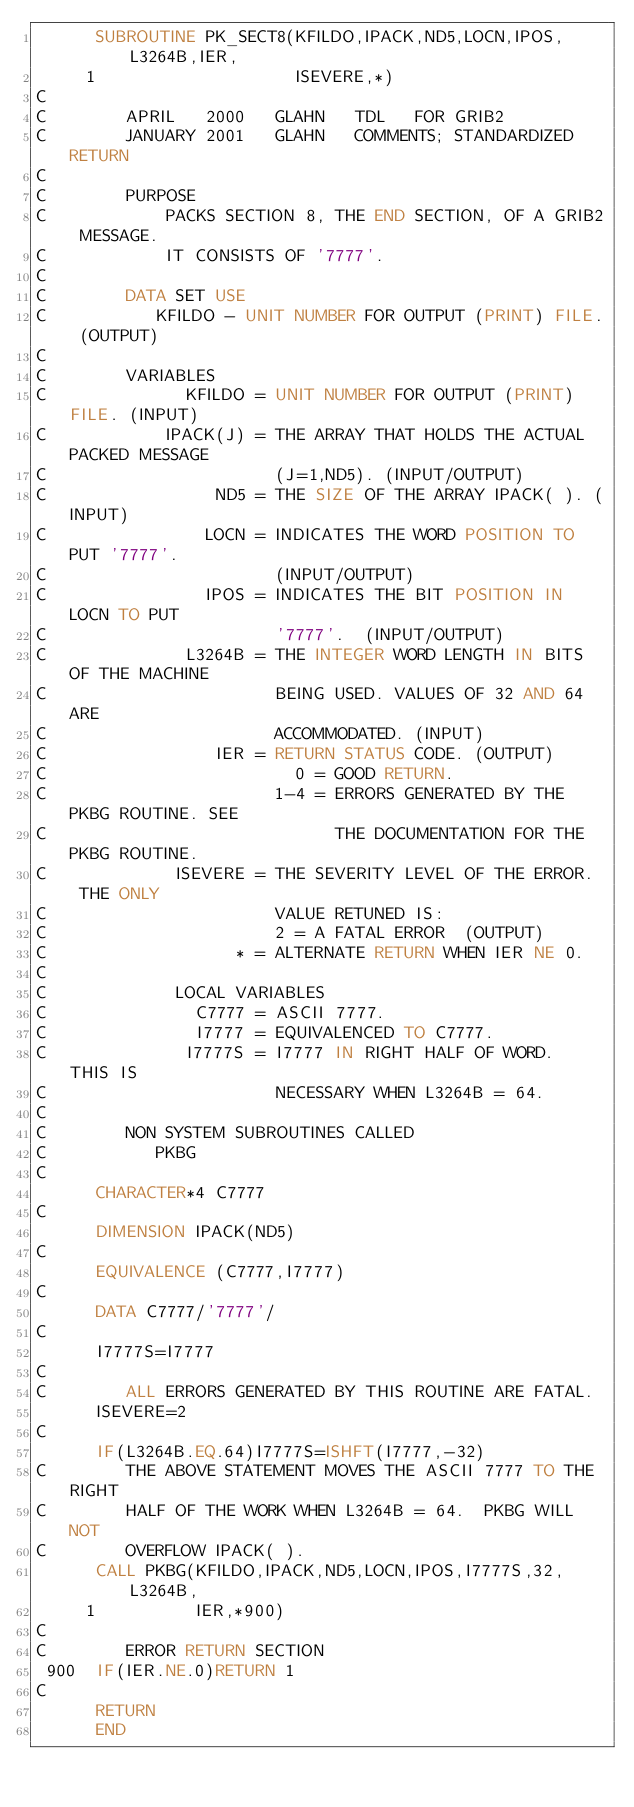<code> <loc_0><loc_0><loc_500><loc_500><_FORTRAN_>      SUBROUTINE PK_SECT8(KFILDO,IPACK,ND5,LOCN,IPOS,L3264B,IER,
     1                    ISEVERE,*)
C
C        APRIL   2000   GLAHN   TDL   FOR GRIB2
C        JANUARY 2001   GLAHN   COMMENTS; STANDARDIZED RETURN
C
C        PURPOSE
C            PACKS SECTION 8, THE END SECTION, OF A GRIB2 MESSAGE.
C            IT CONSISTS OF '7777'.
C
C        DATA SET USE
C           KFILDO - UNIT NUMBER FOR OUTPUT (PRINT) FILE. (OUTPUT)
C
C        VARIABLES
C              KFILDO = UNIT NUMBER FOR OUTPUT (PRINT) FILE. (INPUT)
C            IPACK(J) = THE ARRAY THAT HOLDS THE ACTUAL PACKED MESSAGE
C                       (J=1,ND5). (INPUT/OUTPUT)
C                 ND5 = THE SIZE OF THE ARRAY IPACK( ). (INPUT)
C                LOCN = INDICATES THE WORD POSITION TO PUT '7777'.
C                       (INPUT/OUTPUT)
C                IPOS = INDICATES THE BIT POSITION IN LOCN TO PUT
C                       '7777'.  (INPUT/OUTPUT)
C              L3264B = THE INTEGER WORD LENGTH IN BITS OF THE MACHINE
C                       BEING USED. VALUES OF 32 AND 64 ARE
C                       ACCOMMODATED. (INPUT)
C                 IER = RETURN STATUS CODE. (OUTPUT)
C                         0 = GOOD RETURN.
C                       1-4 = ERRORS GENERATED BY THE PKBG ROUTINE. SEE
C                             THE DOCUMENTATION FOR THE PKBG ROUTINE.
C             ISEVERE = THE SEVERITY LEVEL OF THE ERROR.  THE ONLY
C                       VALUE RETUNED IS:
C                       2 = A FATAL ERROR  (OUTPUT)
C                   * = ALTERNATE RETURN WHEN IER NE 0.
C
C             LOCAL VARIABLES
C               C7777 = ASCII 7777.
C               I7777 = EQUIVALENCED TO C7777.
C              I7777S = I7777 IN RIGHT HALF OF WORD.  THIS IS
C                       NECESSARY WHEN L3264B = 64.
C
C        NON SYSTEM SUBROUTINES CALLED
C           PKBG
C
      CHARACTER*4 C7777
C
      DIMENSION IPACK(ND5)
C
      EQUIVALENCE (C7777,I7777)
C
      DATA C7777/'7777'/
C
      I7777S=I7777
C
C        ALL ERRORS GENERATED BY THIS ROUTINE ARE FATAL.
      ISEVERE=2
C
      IF(L3264B.EQ.64)I7777S=ISHFT(I7777,-32)
C        THE ABOVE STATEMENT MOVES THE ASCII 7777 TO THE RIGHT
C        HALF OF THE WORK WHEN L3264B = 64.  PKBG WILL NOT
C        OVERFLOW IPACK( ).
      CALL PKBG(KFILDO,IPACK,ND5,LOCN,IPOS,I7777S,32,L3264B,
     1          IER,*900)
C
C        ERROR RETURN SECTION
 900  IF(IER.NE.0)RETURN 1
C
      RETURN
      END
</code> 